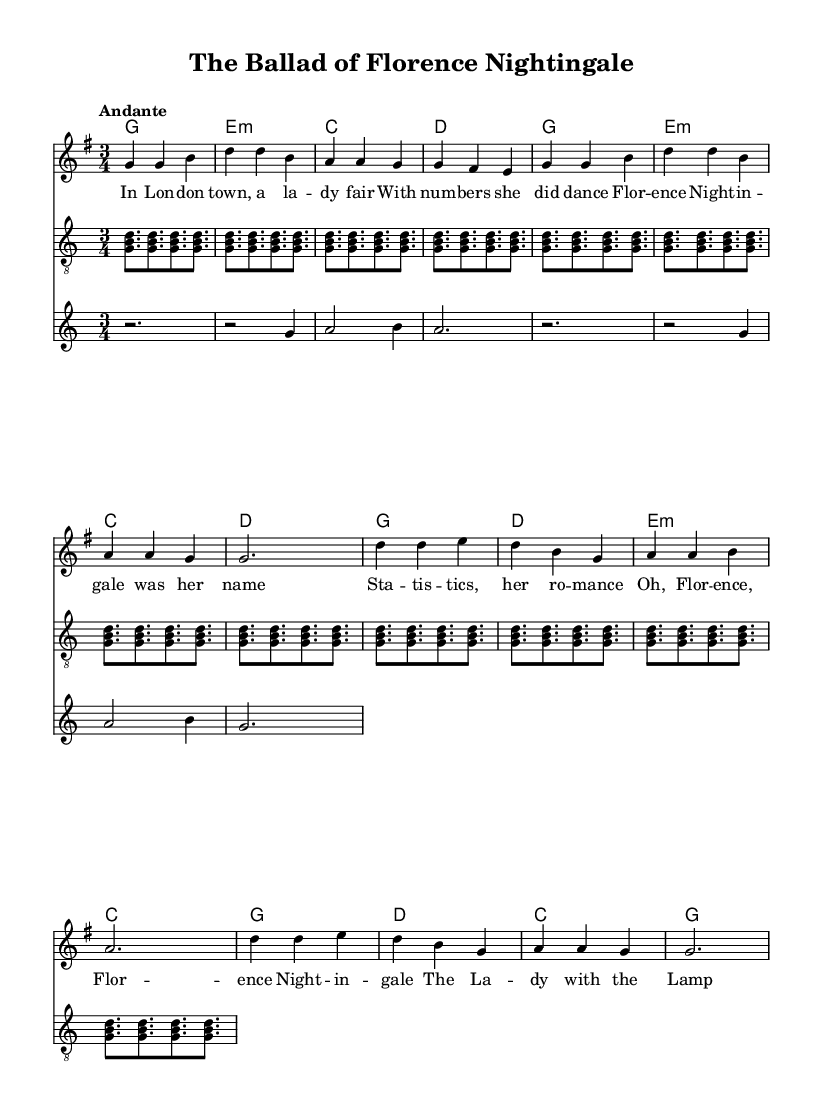What is the key signature of this music? The key signature is G major, which has one sharp (F#). This can be determined from the key signature indicated at the beginning of the staff, which shows the position of the sharps.
Answer: G major What is the time signature of this music? The time signature is three-four time, as indicated by the '3/4' at the beginning of the staff. This means there are three beats per measure and the quarter note receives one beat.
Answer: 3/4 What is the tempo marking given in the music? The tempo marking is "Andante," which is typically interpreted as a moderate walking speed, suggesting a calm and flowing pace for the piece. This is noted just above the staff in the initial markings.
Answer: Andante How many measures are in the verse section? The verse section consists of eight measures, as can be counted by observing the measure lines separating each group of notes in the melody section.
Answer: 8 measures What is the main instrument combination used in this piece? The main instruments used in this piece are voice, guitar, and violin, which can be identified from the separate staves provided for each instrument in the score.
Answer: Voice, guitar, violin What is the lyrical theme of the song? The lyrical theme of the song is about Florence Nightingale and her contributions to statistics, as outlined in the lyrics. The lyrics narrate her story and achievements, emphasizing her impact on healthcare statistics.
Answer: Florence Nightingale 